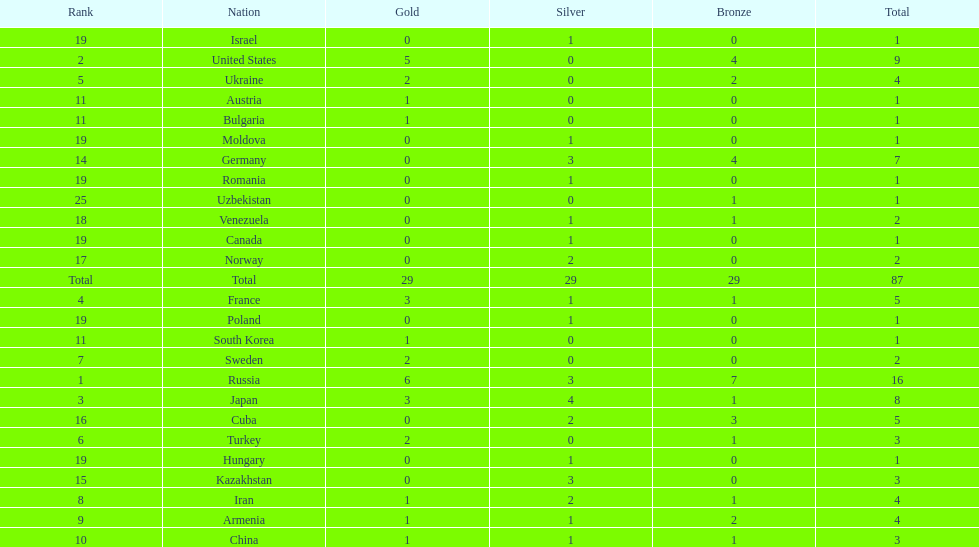Which country had the highest number of medals? Russia. 